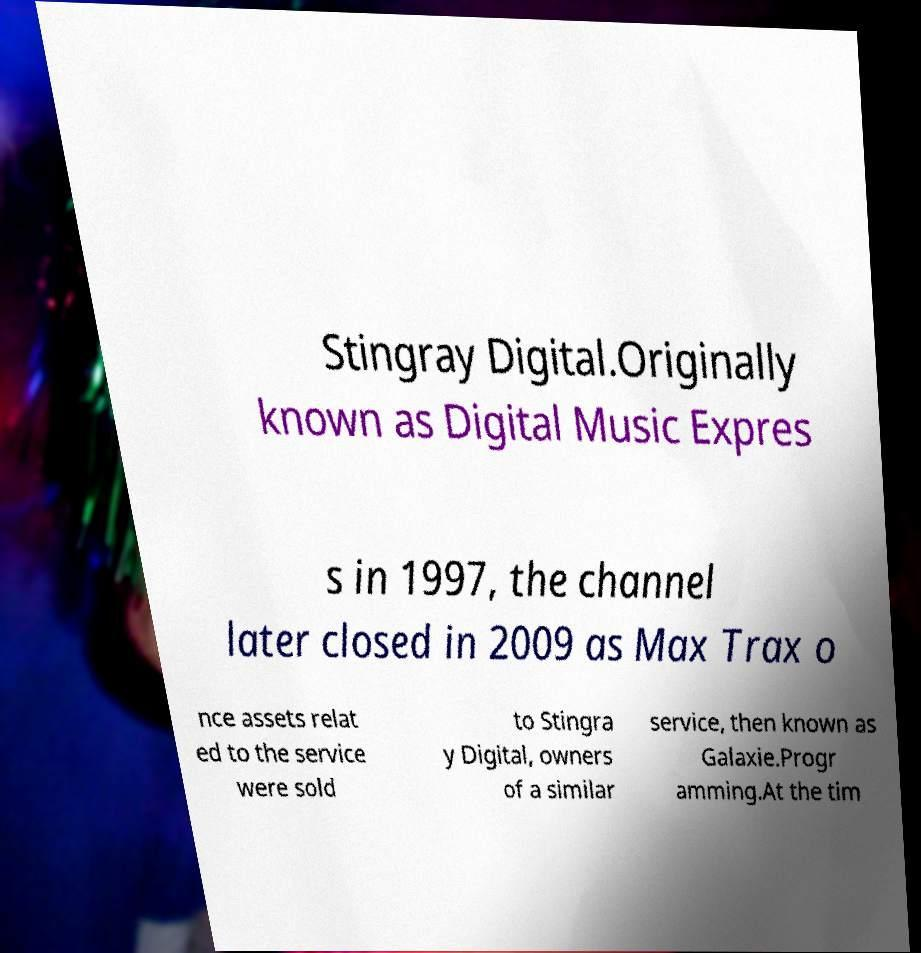Can you read and provide the text displayed in the image?This photo seems to have some interesting text. Can you extract and type it out for me? Stingray Digital.Originally known as Digital Music Expres s in 1997, the channel later closed in 2009 as Max Trax o nce assets relat ed to the service were sold to Stingra y Digital, owners of a similar service, then known as Galaxie.Progr amming.At the tim 